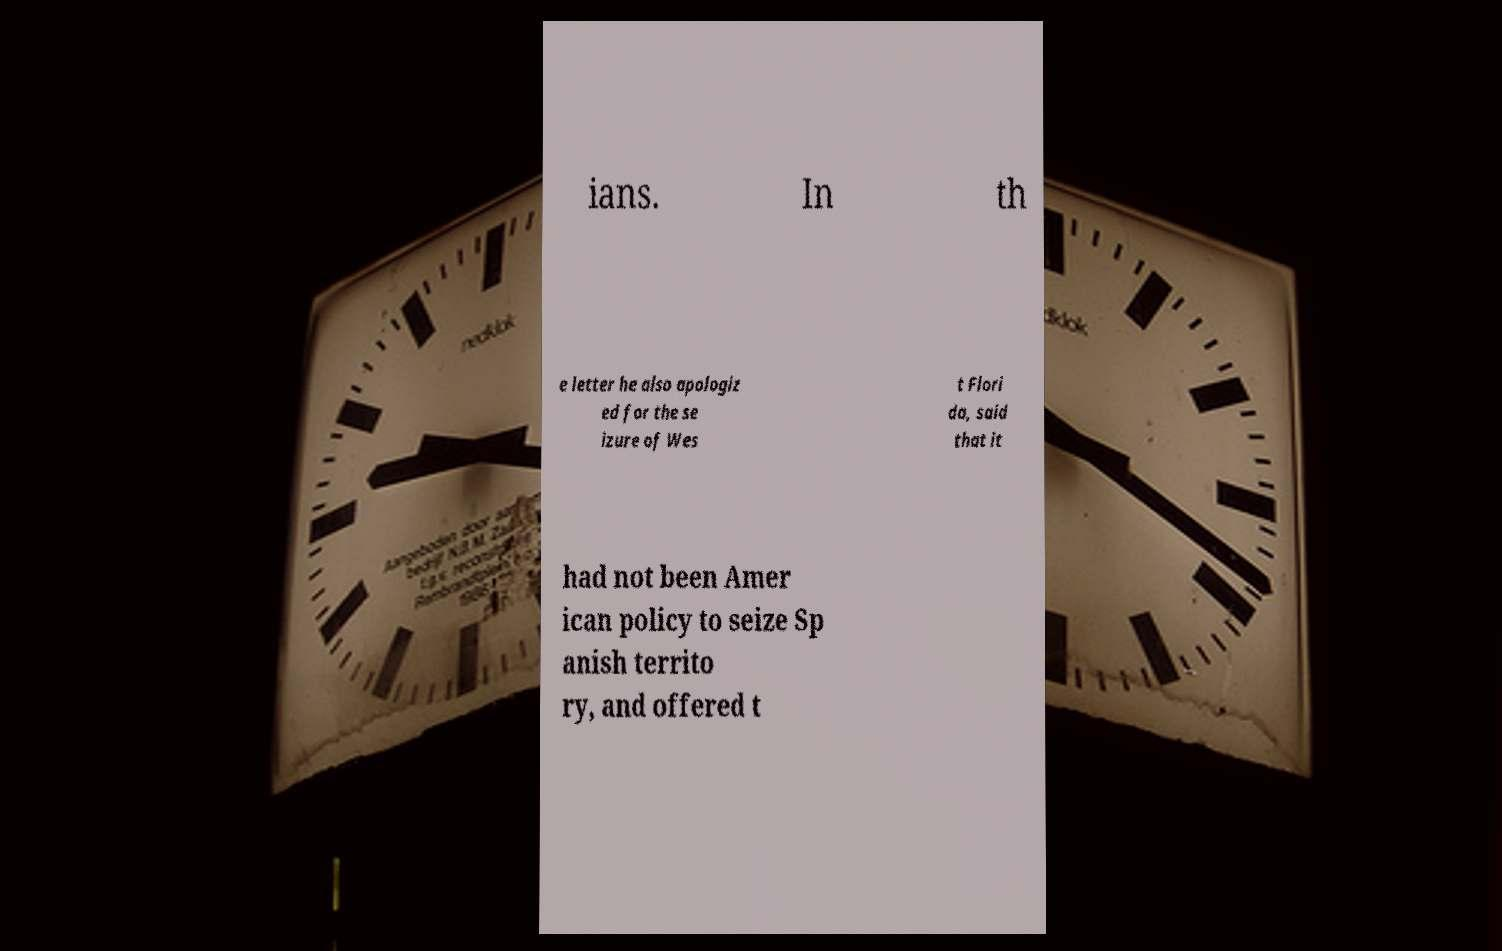I need the written content from this picture converted into text. Can you do that? ians. In th e letter he also apologiz ed for the se izure of Wes t Flori da, said that it had not been Amer ican policy to seize Sp anish territo ry, and offered t 